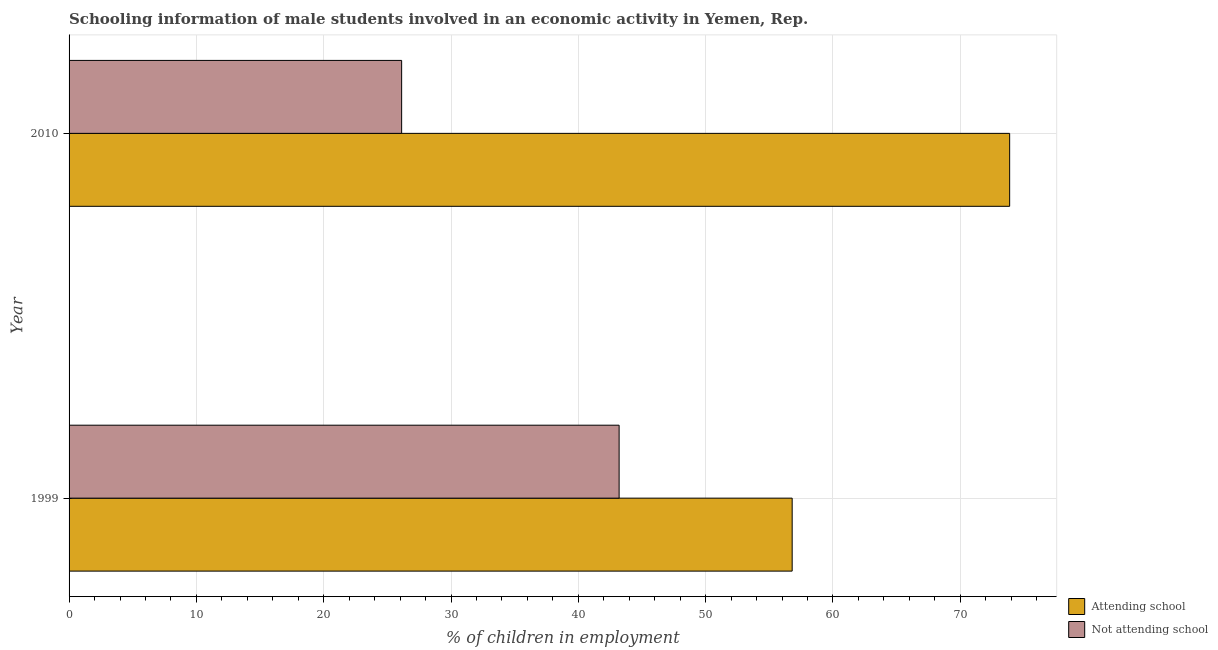How many groups of bars are there?
Give a very brief answer. 2. Are the number of bars on each tick of the Y-axis equal?
Provide a short and direct response. Yes. How many bars are there on the 1st tick from the top?
Give a very brief answer. 2. What is the percentage of employed males who are attending school in 1999?
Provide a succinct answer. 56.8. Across all years, what is the maximum percentage of employed males who are not attending school?
Ensure brevity in your answer.  43.2. Across all years, what is the minimum percentage of employed males who are attending school?
Keep it short and to the point. 56.8. In which year was the percentage of employed males who are not attending school maximum?
Offer a terse response. 1999. What is the total percentage of employed males who are attending school in the graph?
Ensure brevity in your answer.  130.67. What is the difference between the percentage of employed males who are attending school in 1999 and that in 2010?
Keep it short and to the point. -17.08. What is the difference between the percentage of employed males who are not attending school in 2010 and the percentage of employed males who are attending school in 1999?
Offer a very short reply. -30.67. What is the average percentage of employed males who are not attending school per year?
Your answer should be very brief. 34.66. In the year 1999, what is the difference between the percentage of employed males who are not attending school and percentage of employed males who are attending school?
Make the answer very short. -13.59. In how many years, is the percentage of employed males who are attending school greater than 64 %?
Provide a short and direct response. 1. What is the ratio of the percentage of employed males who are attending school in 1999 to that in 2010?
Offer a terse response. 0.77. Is the percentage of employed males who are not attending school in 1999 less than that in 2010?
Offer a terse response. No. In how many years, is the percentage of employed males who are not attending school greater than the average percentage of employed males who are not attending school taken over all years?
Offer a terse response. 1. What does the 2nd bar from the top in 1999 represents?
Your answer should be compact. Attending school. What does the 2nd bar from the bottom in 2010 represents?
Your response must be concise. Not attending school. How many bars are there?
Provide a short and direct response. 4. How many years are there in the graph?
Your response must be concise. 2. Does the graph contain grids?
Your answer should be very brief. Yes. Where does the legend appear in the graph?
Your response must be concise. Bottom right. How many legend labels are there?
Offer a terse response. 2. How are the legend labels stacked?
Your response must be concise. Vertical. What is the title of the graph?
Provide a succinct answer. Schooling information of male students involved in an economic activity in Yemen, Rep. Does "Stunting" appear as one of the legend labels in the graph?
Offer a terse response. No. What is the label or title of the X-axis?
Make the answer very short. % of children in employment. What is the % of children in employment of Attending school in 1999?
Provide a short and direct response. 56.8. What is the % of children in employment in Not attending school in 1999?
Offer a terse response. 43.2. What is the % of children in employment in Attending school in 2010?
Offer a terse response. 73.88. What is the % of children in employment in Not attending school in 2010?
Offer a very short reply. 26.12. Across all years, what is the maximum % of children in employment in Attending school?
Provide a succinct answer. 73.88. Across all years, what is the maximum % of children in employment in Not attending school?
Provide a short and direct response. 43.2. Across all years, what is the minimum % of children in employment of Attending school?
Provide a short and direct response. 56.8. Across all years, what is the minimum % of children in employment in Not attending school?
Your answer should be compact. 26.12. What is the total % of children in employment in Attending school in the graph?
Ensure brevity in your answer.  130.67. What is the total % of children in employment in Not attending school in the graph?
Your answer should be very brief. 69.33. What is the difference between the % of children in employment of Attending school in 1999 and that in 2010?
Offer a terse response. -17.08. What is the difference between the % of children in employment of Not attending school in 1999 and that in 2010?
Your response must be concise. 17.08. What is the difference between the % of children in employment of Attending school in 1999 and the % of children in employment of Not attending school in 2010?
Offer a terse response. 30.67. What is the average % of children in employment in Attending school per year?
Your answer should be compact. 65.34. What is the average % of children in employment in Not attending school per year?
Your answer should be very brief. 34.66. In the year 1999, what is the difference between the % of children in employment of Attending school and % of children in employment of Not attending school?
Ensure brevity in your answer.  13.59. In the year 2010, what is the difference between the % of children in employment of Attending school and % of children in employment of Not attending school?
Give a very brief answer. 47.76. What is the ratio of the % of children in employment in Attending school in 1999 to that in 2010?
Make the answer very short. 0.77. What is the ratio of the % of children in employment in Not attending school in 1999 to that in 2010?
Your answer should be compact. 1.65. What is the difference between the highest and the second highest % of children in employment of Attending school?
Ensure brevity in your answer.  17.08. What is the difference between the highest and the second highest % of children in employment in Not attending school?
Make the answer very short. 17.08. What is the difference between the highest and the lowest % of children in employment in Attending school?
Your answer should be very brief. 17.08. What is the difference between the highest and the lowest % of children in employment in Not attending school?
Your answer should be very brief. 17.08. 